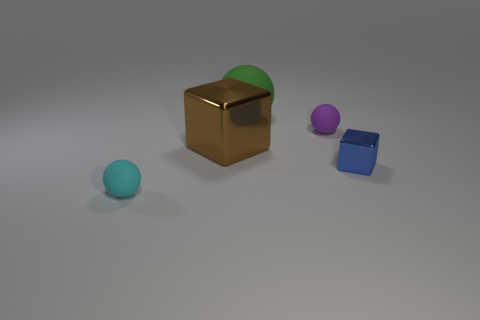Does the blue block have the same material as the cyan thing?
Offer a terse response. No. There is a thing that is both right of the large matte thing and behind the blue thing; how big is it?
Your response must be concise. Small. What is the shape of the cyan thing that is the same size as the purple ball?
Provide a succinct answer. Sphere. The block left of the small shiny object on the right side of the tiny thing that is behind the brown cube is made of what material?
Provide a short and direct response. Metal. Does the tiny blue metal object that is to the right of the large rubber ball have the same shape as the tiny rubber object left of the large rubber thing?
Give a very brief answer. No. How many other objects are there of the same material as the brown thing?
Offer a very short reply. 1. Is the material of the tiny sphere in front of the tiny purple matte thing the same as the cube that is right of the big green sphere?
Your response must be concise. No. What shape is the small blue object that is made of the same material as the brown object?
Give a very brief answer. Cube. Is there any other thing that is the same color as the big matte ball?
Give a very brief answer. No. What number of green matte balls are there?
Your response must be concise. 1. 